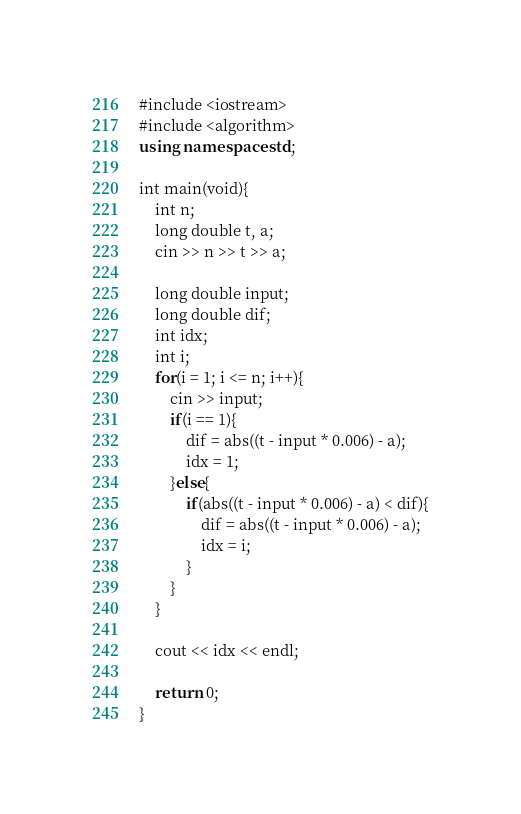<code> <loc_0><loc_0><loc_500><loc_500><_C++_>#include <iostream>
#include <algorithm>
using namespace std;

int main(void){
    int n;
    long double t, a;
    cin >> n >> t >> a;
    
    long double input;
    long double dif;
    int idx;
    int i;
    for(i = 1; i <= n; i++){
        cin >> input;
        if(i == 1){
            dif = abs((t - input * 0.006) - a);
            idx = 1;
        }else{
            if(abs((t - input * 0.006) - a) < dif){
                dif = abs((t - input * 0.006) - a);
                idx = i;
            }
        }
    }
    
    cout << idx << endl;
    
    return 0;
}
</code> 